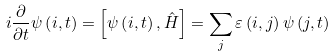<formula> <loc_0><loc_0><loc_500><loc_500>i \frac { \partial } { \partial t } \psi \left ( i , t \right ) = \left [ \psi \left ( i , t \right ) , \hat { H } \right ] = \sum _ { j } \varepsilon \left ( i , j \right ) \psi \left ( j , t \right )</formula> 